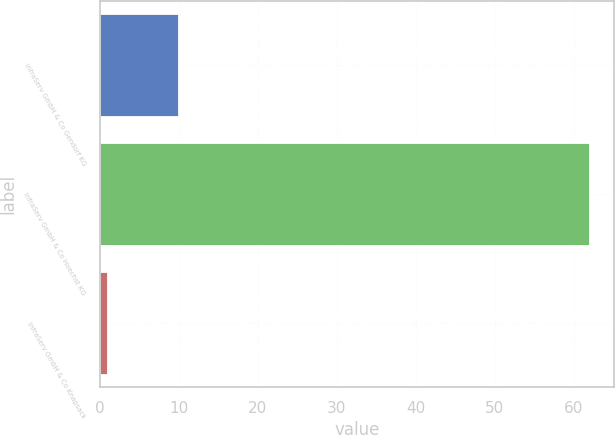<chart> <loc_0><loc_0><loc_500><loc_500><bar_chart><fcel>InfraServ GmbH & Co Gendorf KG<fcel>InfraServ GmbH & Co Hoechst KG<fcel>InfraServ GmbH & Co Knapsack<nl><fcel>10<fcel>62<fcel>1<nl></chart> 